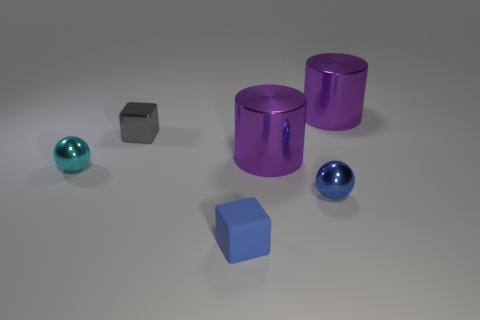Add 1 purple objects. How many objects exist? 7 Subtract all cyan spheres. How many spheres are left? 1 Subtract all cubes. How many objects are left? 4 Subtract all blue cubes. Subtract all red cylinders. How many cubes are left? 1 Subtract all tiny green metallic things. Subtract all blocks. How many objects are left? 4 Add 6 shiny spheres. How many shiny spheres are left? 8 Add 5 blue metal things. How many blue metal things exist? 6 Subtract 0 yellow cylinders. How many objects are left? 6 